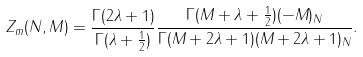Convert formula to latex. <formula><loc_0><loc_0><loc_500><loc_500>Z _ { m } ( N , M ) = \frac { \Gamma ( 2 \lambda + 1 ) } { \Gamma ( \lambda + \frac { 1 } { 2 } ) } \frac { \Gamma ( M + \lambda + \frac { 1 } { 2 } ) ( - M ) _ { N } } { \Gamma ( M + 2 \lambda + 1 ) ( M + 2 \lambda + 1 ) _ { N } } .</formula> 